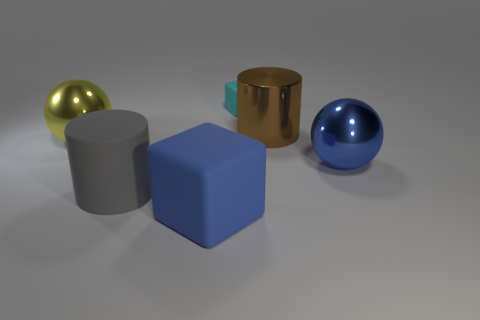What is the color of the metallic object that is both in front of the brown shiny cylinder and right of the big yellow shiny ball? blue 